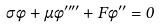Convert formula to latex. <formula><loc_0><loc_0><loc_500><loc_500>\sigma \ddot { \phi } + \mu \phi ^ { \prime \prime \prime \prime } + F \phi ^ { \prime \prime } = 0</formula> 